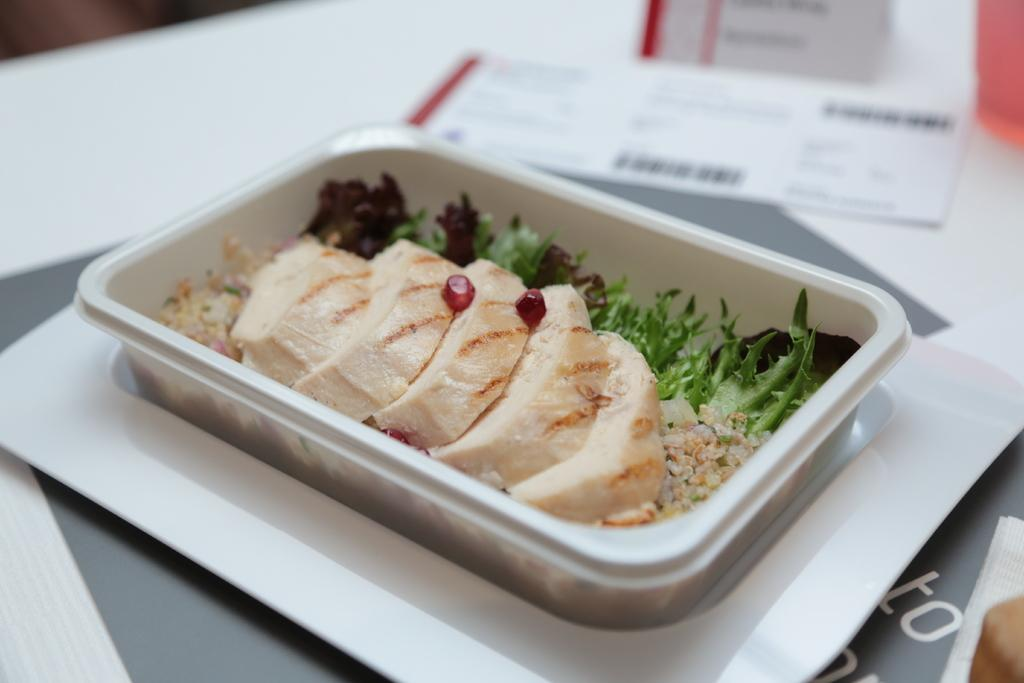What piece of furniture is present in the image? There is a table in the image. What is placed on the table? There is a plate on the table. What is on top of the plate? There is a box on the plate. What is inside the box? There are food items in the box. Can you describe the background of the image? The background of the image is blurred. Are there any giants walking on the sidewalk in the image? There is no sidewalk or giants present in the image. Can you tell me where the nearest shop is located in the image? There is no information about a shop in the image. 